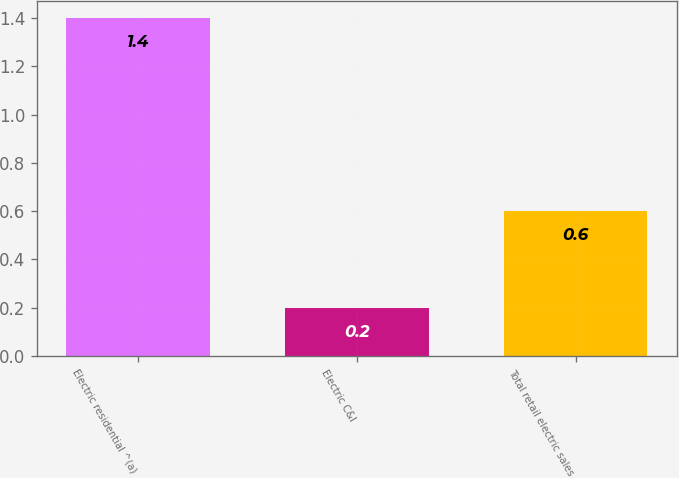<chart> <loc_0><loc_0><loc_500><loc_500><bar_chart><fcel>Electric residential ^(a)<fcel>Electric C&I<fcel>Total retail electric sales<nl><fcel>1.4<fcel>0.2<fcel>0.6<nl></chart> 